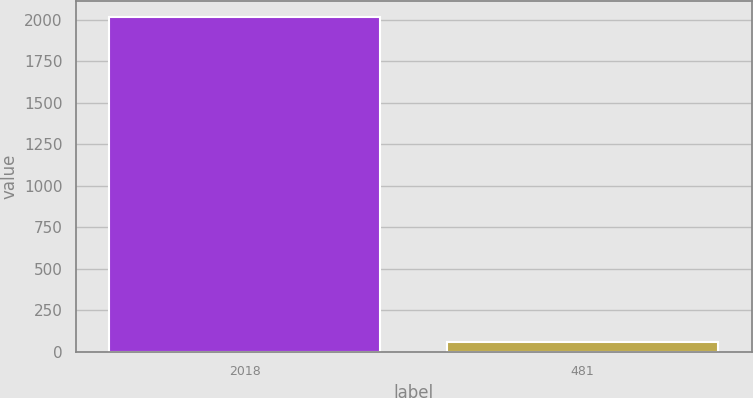Convert chart to OTSL. <chart><loc_0><loc_0><loc_500><loc_500><bar_chart><fcel>2018<fcel>481<nl><fcel>2016<fcel>58.4<nl></chart> 